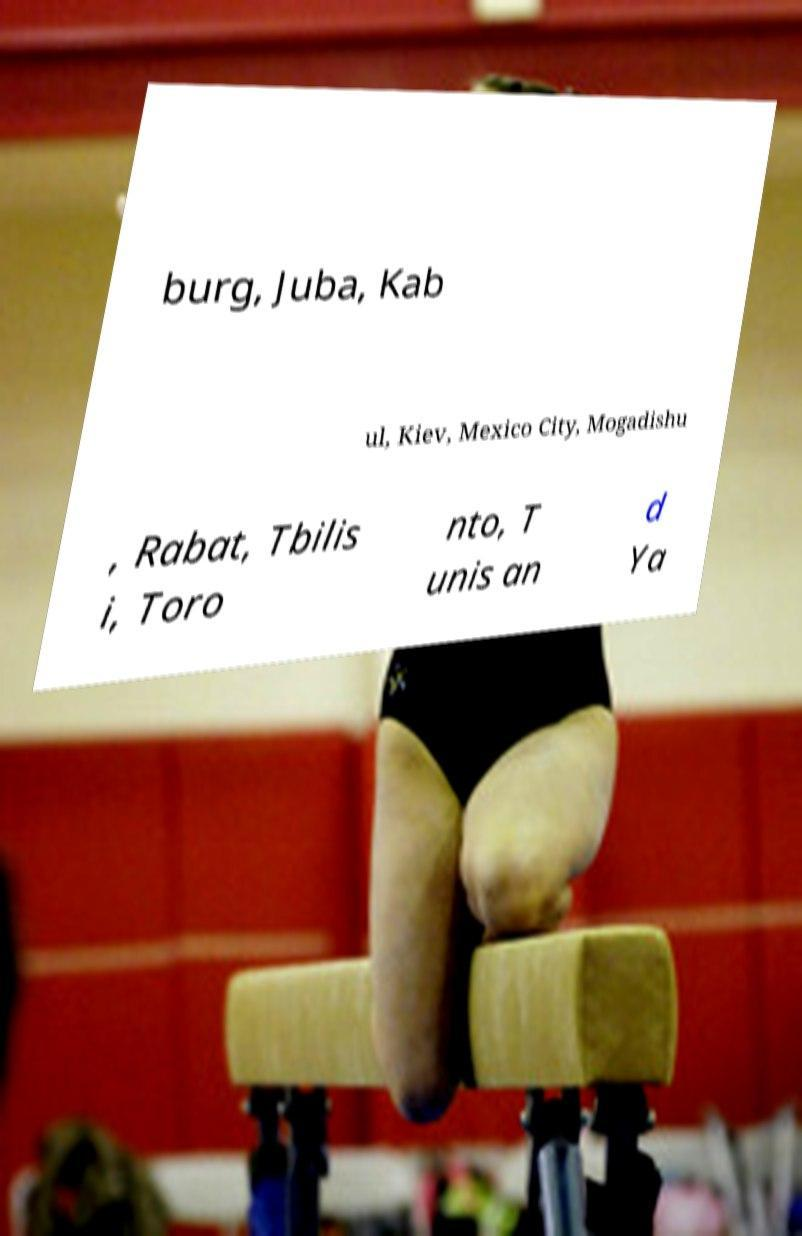Please read and relay the text visible in this image. What does it say? burg, Juba, Kab ul, Kiev, Mexico City, Mogadishu , Rabat, Tbilis i, Toro nto, T unis an d Ya 